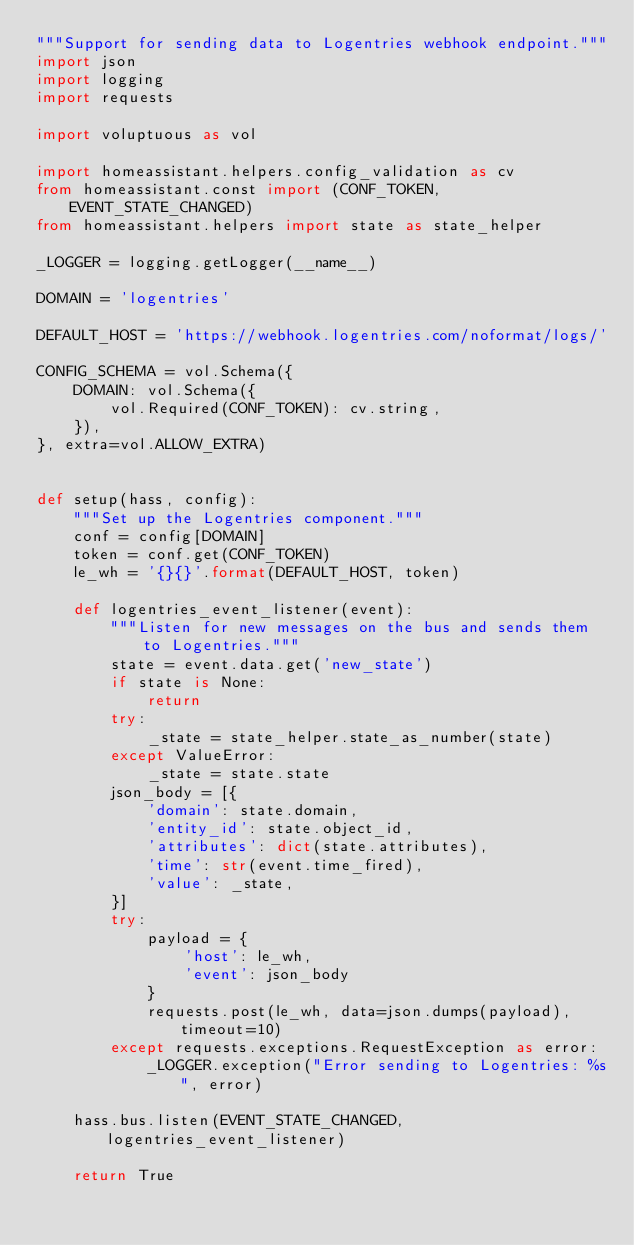Convert code to text. <code><loc_0><loc_0><loc_500><loc_500><_Python_>"""Support for sending data to Logentries webhook endpoint."""
import json
import logging
import requests

import voluptuous as vol

import homeassistant.helpers.config_validation as cv
from homeassistant.const import (CONF_TOKEN, EVENT_STATE_CHANGED)
from homeassistant.helpers import state as state_helper

_LOGGER = logging.getLogger(__name__)

DOMAIN = 'logentries'

DEFAULT_HOST = 'https://webhook.logentries.com/noformat/logs/'

CONFIG_SCHEMA = vol.Schema({
    DOMAIN: vol.Schema({
        vol.Required(CONF_TOKEN): cv.string,
    }),
}, extra=vol.ALLOW_EXTRA)


def setup(hass, config):
    """Set up the Logentries component."""
    conf = config[DOMAIN]
    token = conf.get(CONF_TOKEN)
    le_wh = '{}{}'.format(DEFAULT_HOST, token)

    def logentries_event_listener(event):
        """Listen for new messages on the bus and sends them to Logentries."""
        state = event.data.get('new_state')
        if state is None:
            return
        try:
            _state = state_helper.state_as_number(state)
        except ValueError:
            _state = state.state
        json_body = [{
            'domain': state.domain,
            'entity_id': state.object_id,
            'attributes': dict(state.attributes),
            'time': str(event.time_fired),
            'value': _state,
        }]
        try:
            payload = {
                'host': le_wh,
                'event': json_body
            }
            requests.post(le_wh, data=json.dumps(payload), timeout=10)
        except requests.exceptions.RequestException as error:
            _LOGGER.exception("Error sending to Logentries: %s", error)

    hass.bus.listen(EVENT_STATE_CHANGED, logentries_event_listener)

    return True
</code> 